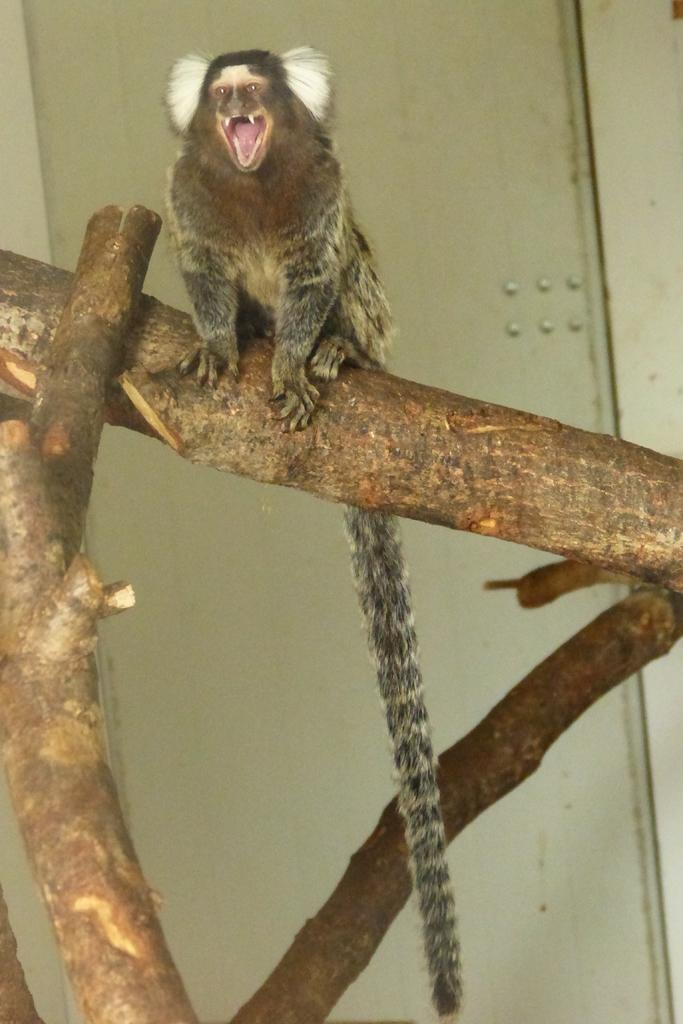What type of animal can be seen in the image? There is an animal in the image, but its specific type cannot be determined from the provided facts. Where is the animal located in the image? The animal is sitting on a tree in the image. What can be seen in the background of the image? There is a white color wall in the background of the image. What type of wrench is the animal using to fix the snail's shell in the image? There is no wrench or snail present in the image, and therefore no such activity can be observed. 